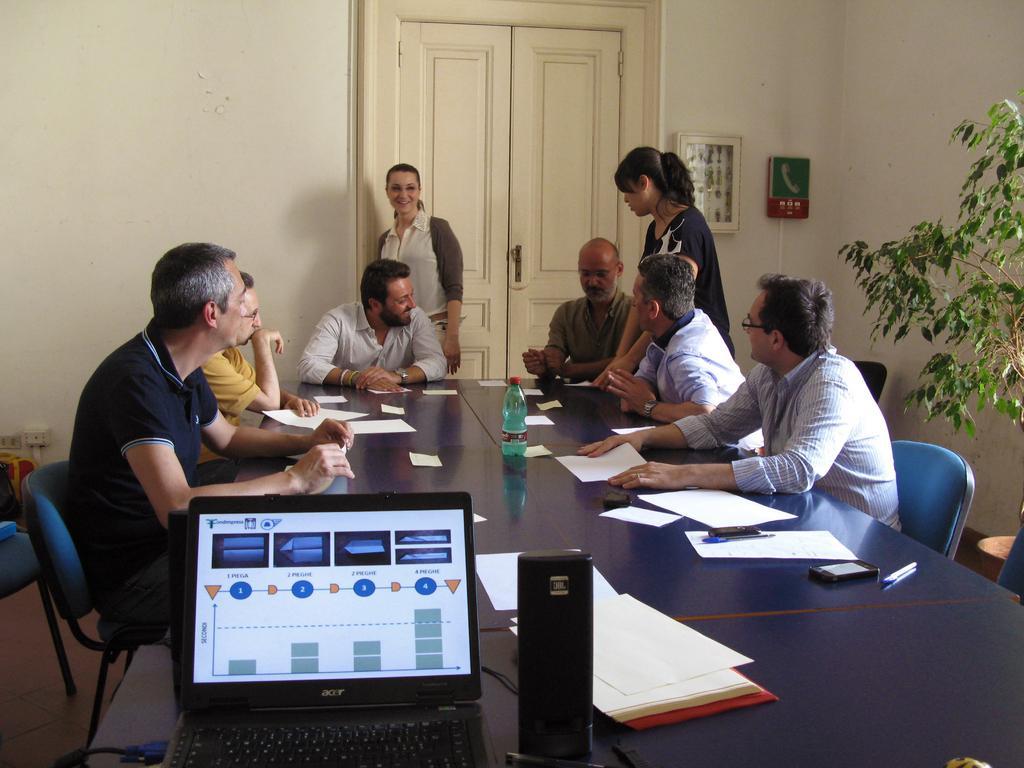How would you summarize this image in a sentence or two? This picture is clicked inside the room. Here, we see six men sitting on chair around the table and two women standing. On table, we see water bottle, papers and laptop, and mobile phone. Beside them, we see a plant and on background, we see a white door and white wall on which photo frames are placed. 